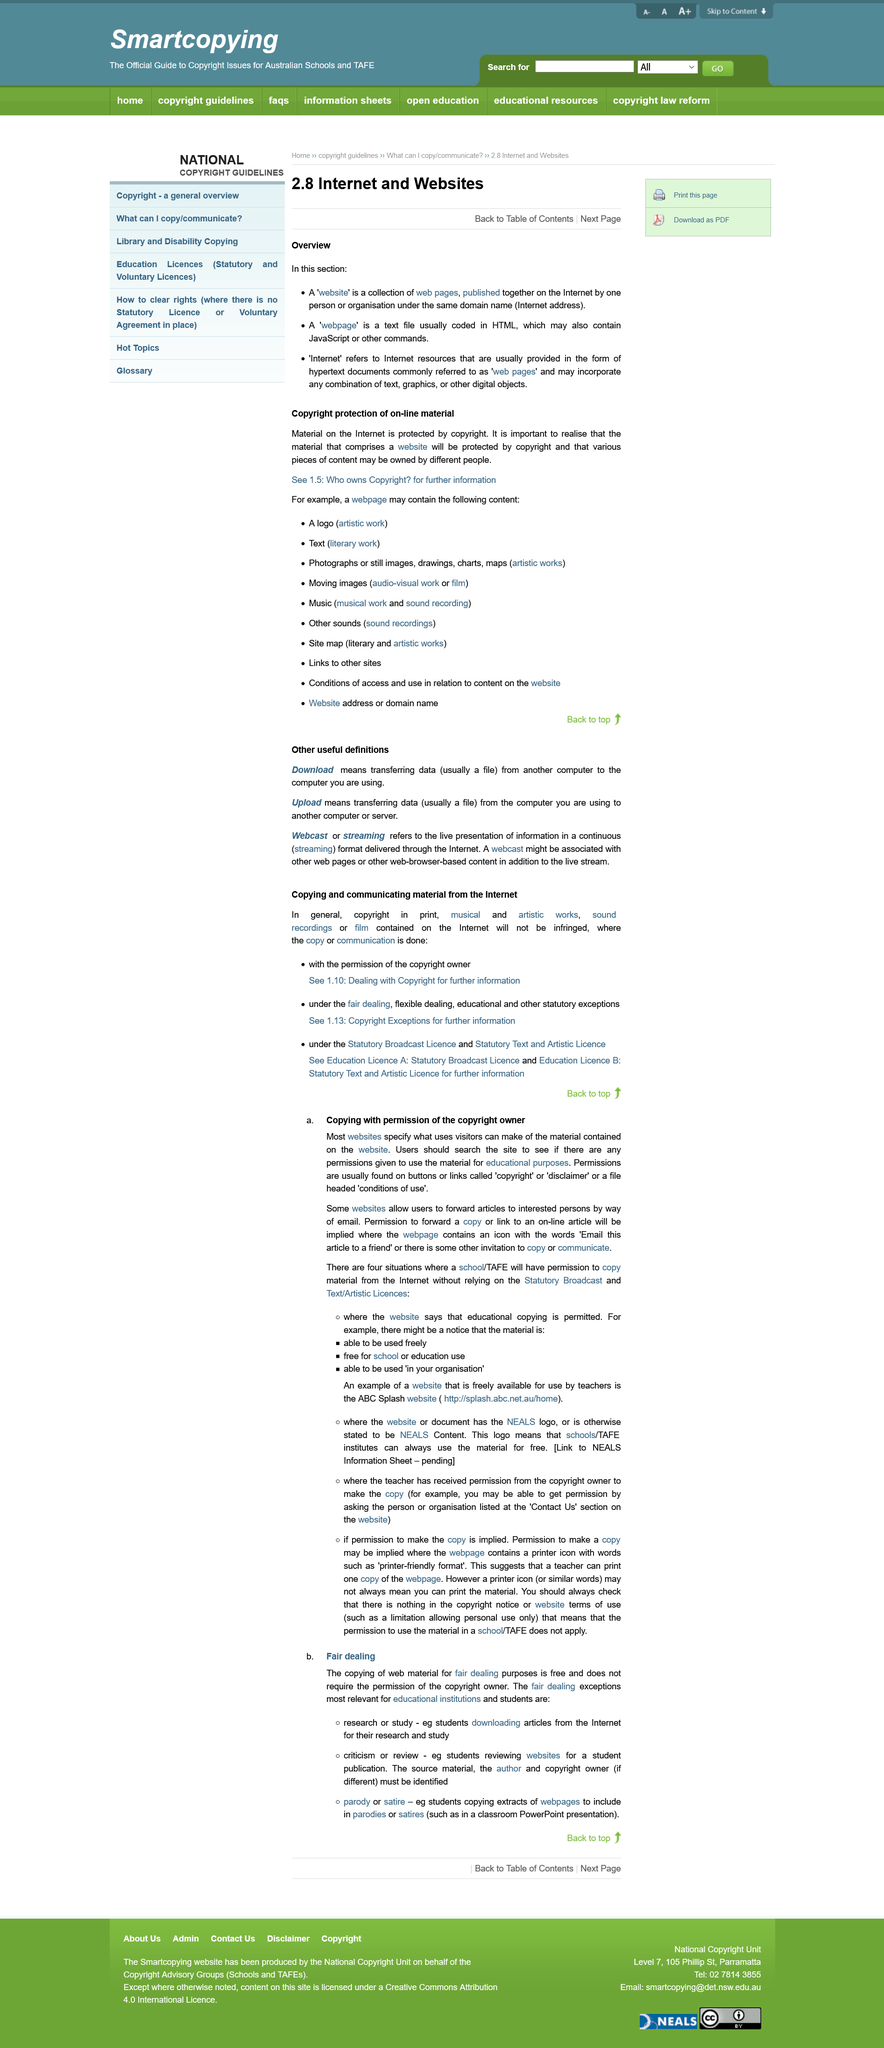Mention a couple of crucial points in this snapshot. There are a total of 3 definitions provided. A webpage is typically coded in HTML. To determine whether the copyright owner has granted permission to reproduce material from a website, look for buttons, links, or a file containing the relevant permissions. The title of the page is "Internet and Websites. This section is the overview, which is located in the part of the page. 